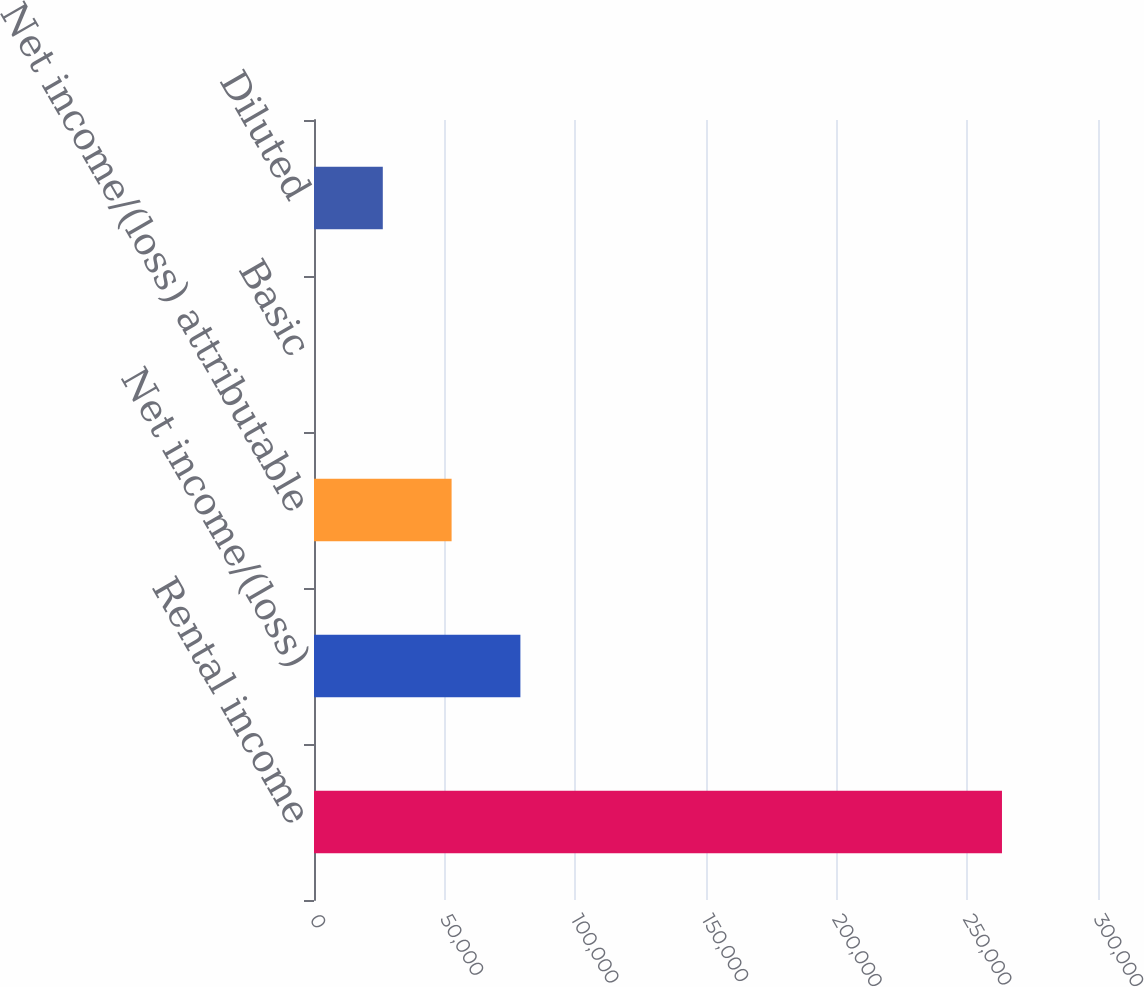Convert chart. <chart><loc_0><loc_0><loc_500><loc_500><bar_chart><fcel>Rental income<fcel>Net income/(loss)<fcel>Net income/(loss) attributable<fcel>Basic<fcel>Diluted<nl><fcel>263256<fcel>78976.8<fcel>52651.2<fcel>0.07<fcel>26325.7<nl></chart> 